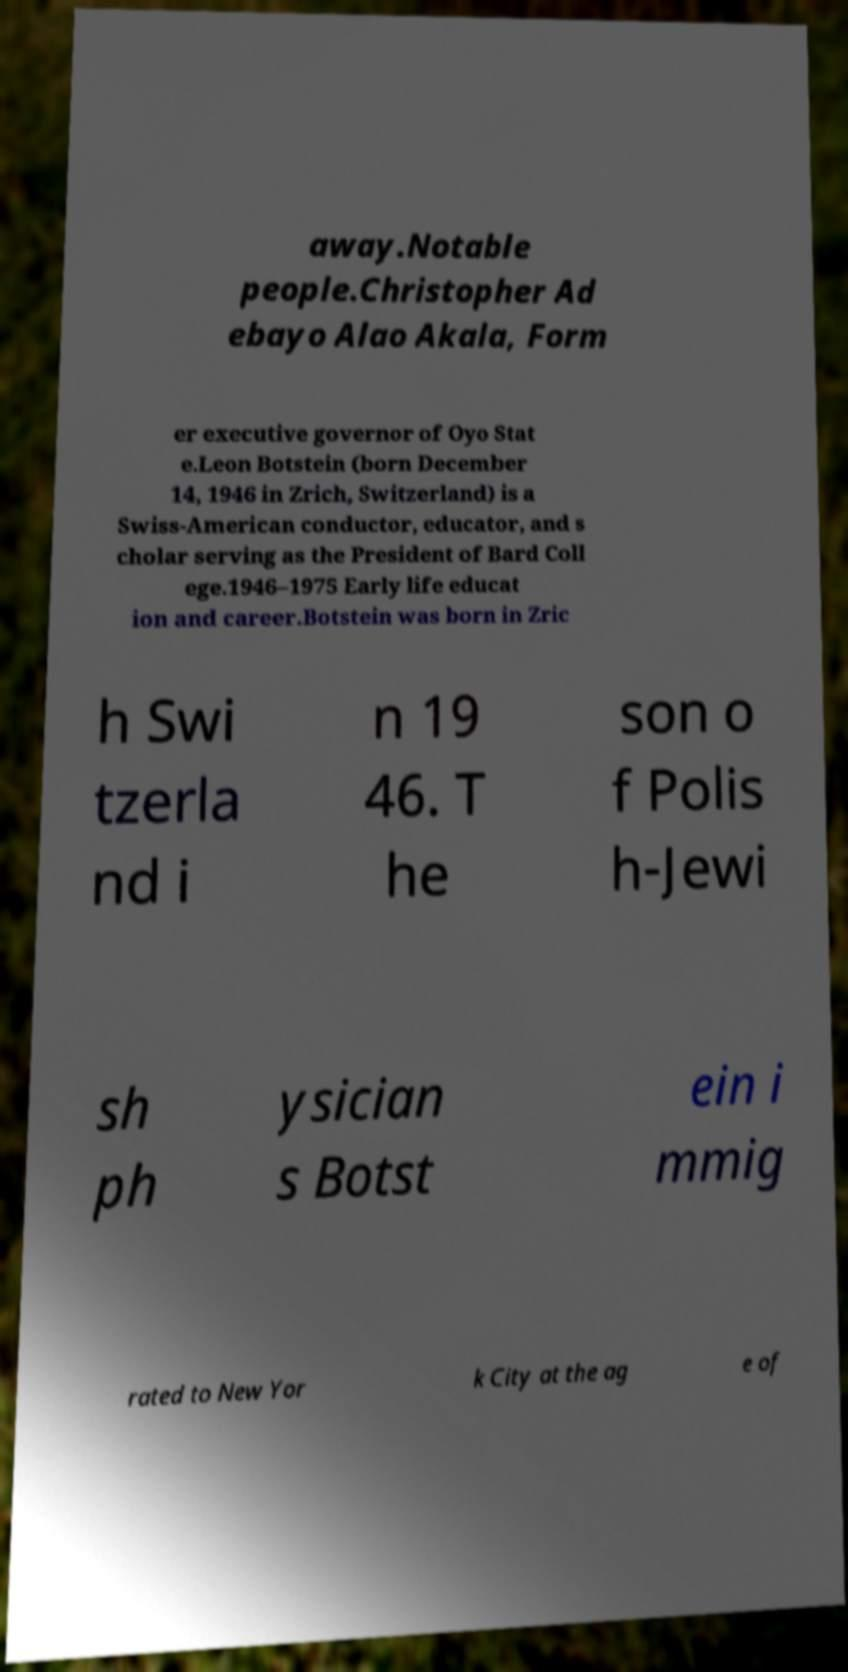I need the written content from this picture converted into text. Can you do that? away.Notable people.Christopher Ad ebayo Alao Akala, Form er executive governor of Oyo Stat e.Leon Botstein (born December 14, 1946 in Zrich, Switzerland) is a Swiss-American conductor, educator, and s cholar serving as the President of Bard Coll ege.1946–1975 Early life educat ion and career.Botstein was born in Zric h Swi tzerla nd i n 19 46. T he son o f Polis h-Jewi sh ph ysician s Botst ein i mmig rated to New Yor k City at the ag e of 